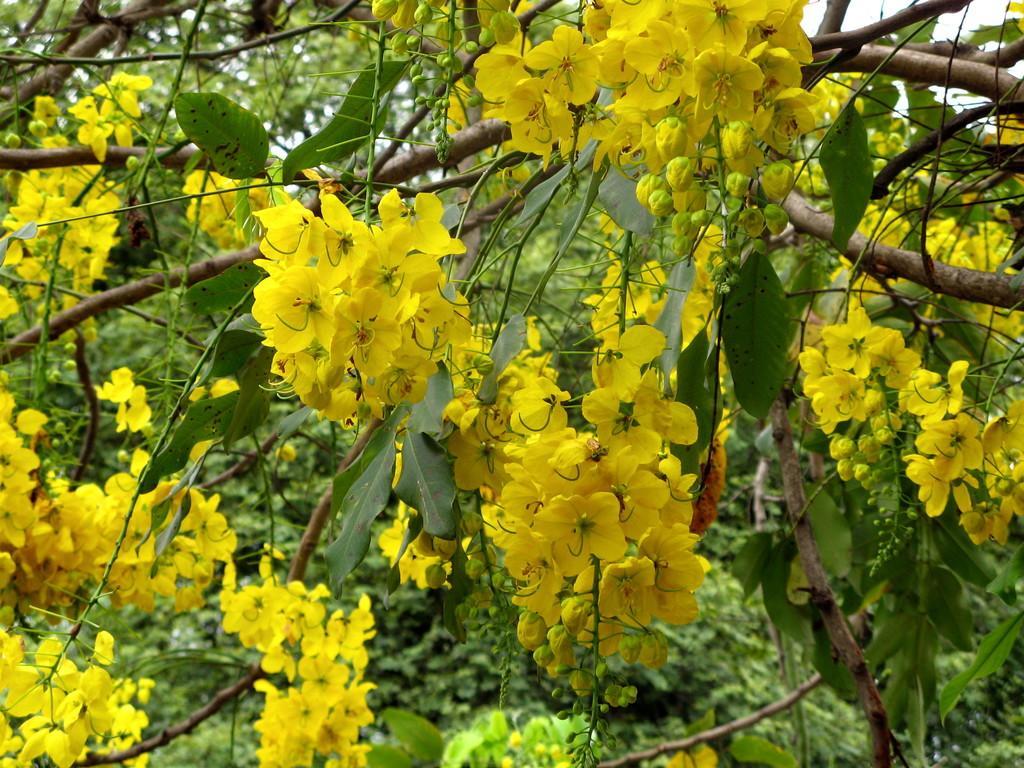In one or two sentences, can you explain what this image depicts? In this image we can see few trees with flowers. 